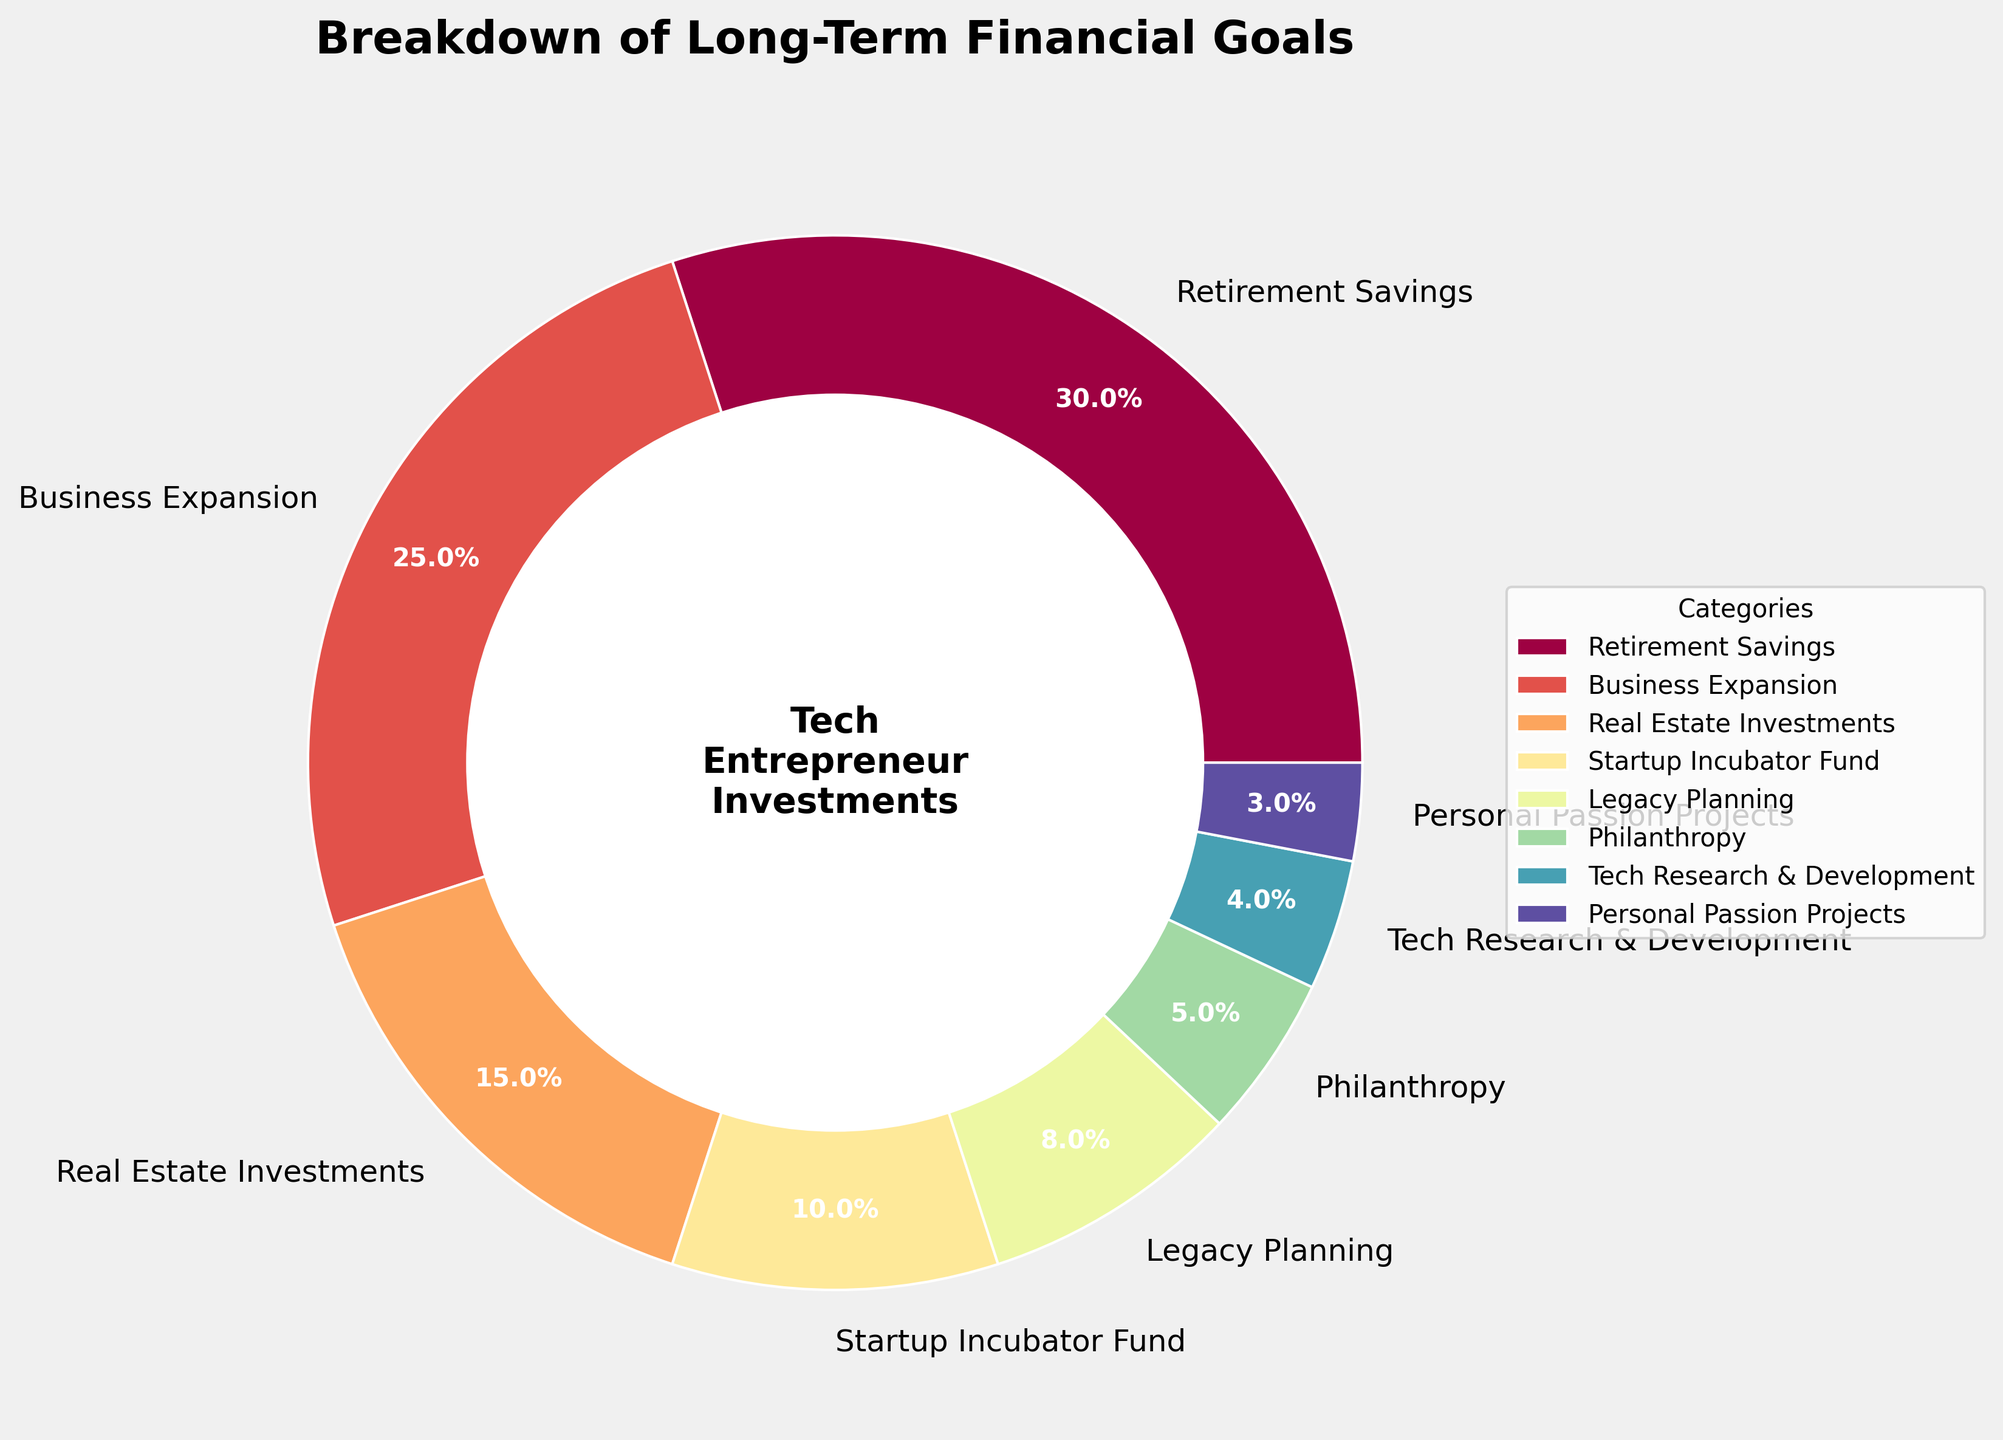What is the largest category in the financial goals pie chart? The largest category is identified by the segment with the highest percentage. From the pie chart, 'Retirement Savings' has the largest segment with 30%.
Answer: Retirement Savings Which category has a larger share: Business Expansion or Real Estate Investments? Comparing the two segments visually, 'Business Expansion' has a greater share (25%) compared to 'Real Estate Investments' (15%).
Answer: Business Expansion What is the combined percentage of Retirement Savings and Business Expansion? Add the percentages of 'Retirement Savings' (30%) and 'Business Expansion' (25%) to get the combined percentage: 30% + 25% = 55%.
Answer: 55% How does the percentage of Legacy Planning compare to that of Philanthropy? Visually comparing the two segments, 'Legacy Planning' has a higher percentage (8%) than 'Philanthropy' (5%).
Answer: Legacy Planning What is the least common financial goal in the chart? The smallest segment represents the least common goal. From the chart, 'Personal Passion Projects' has the smallest percentage at 3%.
Answer: Personal Passion Projects Which categories together account for more than 50% of the chart? Summing the largest categories sequentially until exceeding 50%: 'Retirement Savings' (30%), 'Business Expansion' (25%). Combined, they total 55%.
Answer: Retirement Savings and Business Expansion How much more is allocated to Real Estate Investments compared to Tech Research & Development? The difference between 'Real Estate Investments' (15%) and 'Tech Research & Development' (4%) is calculated as: 15% - 4% = 11%.
Answer: 11% What is the combined percentage of the three smallest categories? Add the smallest segments: 'Personal Passion Projects' (3%), 'Tech Research & Development' (4%), and 'Philanthropy' (5%) to get the total: 3% + 4% + 5% = 12%.
Answer: 12% Which category is depicted with a green wedge in the visualization? Identify the color of the segment corresponding to each category. The segment colored green in the pie chart represents 'Real Estate Investments'.
Answer: Real Estate Investments 